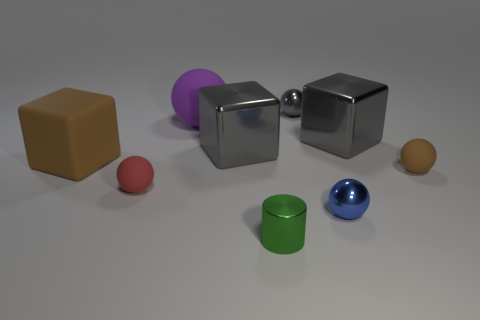How many objects in the image have symmetry? There are five objects with symmetry visible in the image: the two cubes, the sphere, the cylinder, and the cone. 